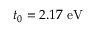<formula> <loc_0><loc_0><loc_500><loc_500>t _ { 0 } = 2 . 1 7 \ e V</formula> 